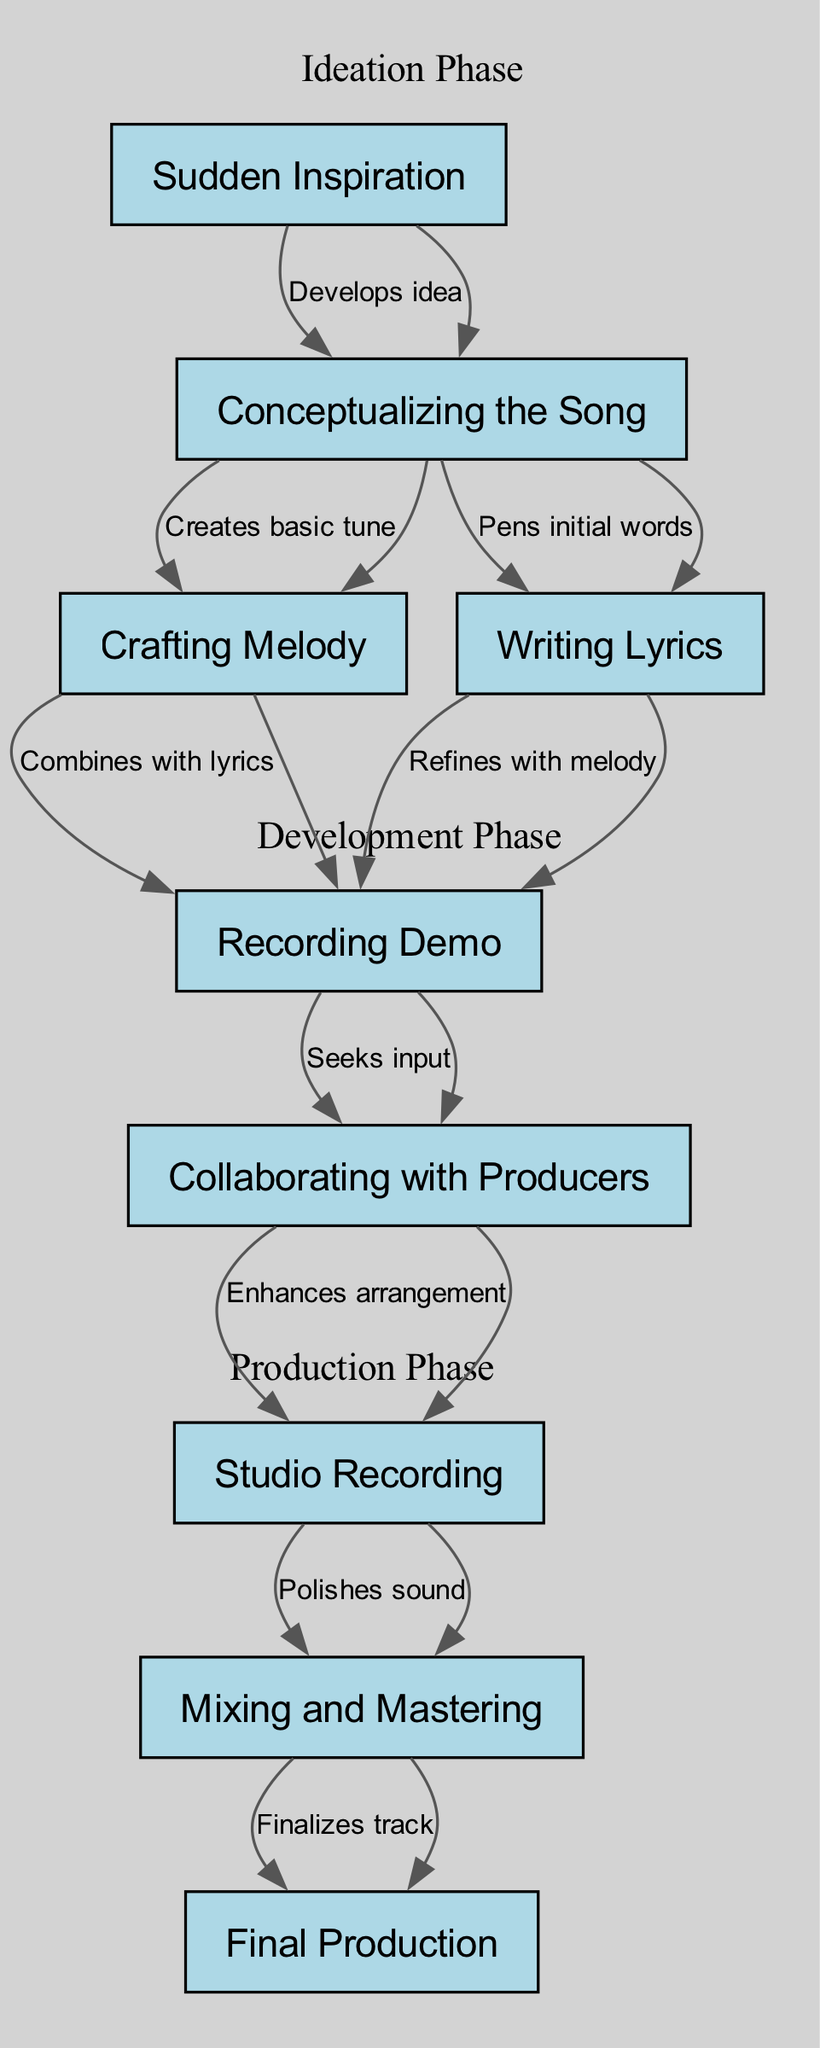What is the first step in Parker Rimes' songwriting process? The first step in the diagram is "Sudden Inspiration," which is the starting point of the songwriting process, leading to the development of the song idea.
Answer: Sudden Inspiration How many nodes are there in the diagram? By counting the individual processes or stages listed in the nodes section of the diagram, we find that there are a total of nine distinct nodes illustrating different parts of the songwriting process.
Answer: 9 Which two nodes are connected by the label "Creates basic tune"? By inspecting the edges in the diagram, the connection that has the label "Creates basic tune" indicates the relationship between the "Conceptualizing the Song" node and the "Crafting Melody" node.
Answer: Conceptualizing the Song, Crafting Melody What follows after the "Recording Demo" stage? Looking at the flow of the diagram, the stage that logically follows "Recording Demo" is "Collaborating with Producers." This indicates that feedback and collaboration come after the demo recording stage.
Answer: Collaborating with Producers How many phases are represented in the diagram? Considering the subgraphs, we identify three distinct phases: the Ideation Phase, the Development Phase, and the Production Phase. Each phase groups specific stages of the songwriting process together.
Answer: 3 What stage leads to "Final Production"? Following the flow from "Mixing and Mastering," which is the penultimate step, it connects to the last stage in the process, "Final Production." This indicates that mixing and mastering are crucial before arriving at the finished product.
Answer: Final Production Which node directly connects to "Polishes sound"? By examining the edges, we see that "Studio Recording" has a direct connection labeled "Polishes sound" leading to "Mixing and Mastering." This shows the progression from recording to mixing and enhancing sound quality.
Answer: Studio Recording How many edges are there in the diagram? Counting all the edges that represent connections between nodes, we determine there are a total of eight edges that outline the relationships and flow of the songwriting process.
Answer: 8 What is the relationship between "Crafting Melody" and "Recording Demo"? The relationship between "Crafting Melody" and "Recording Demo," based on the flow between the two nodes, is that the lyrics are combined with the melody to create the demo recording, as indicated by the edge connecting them.
Answer: Combines with lyrics 